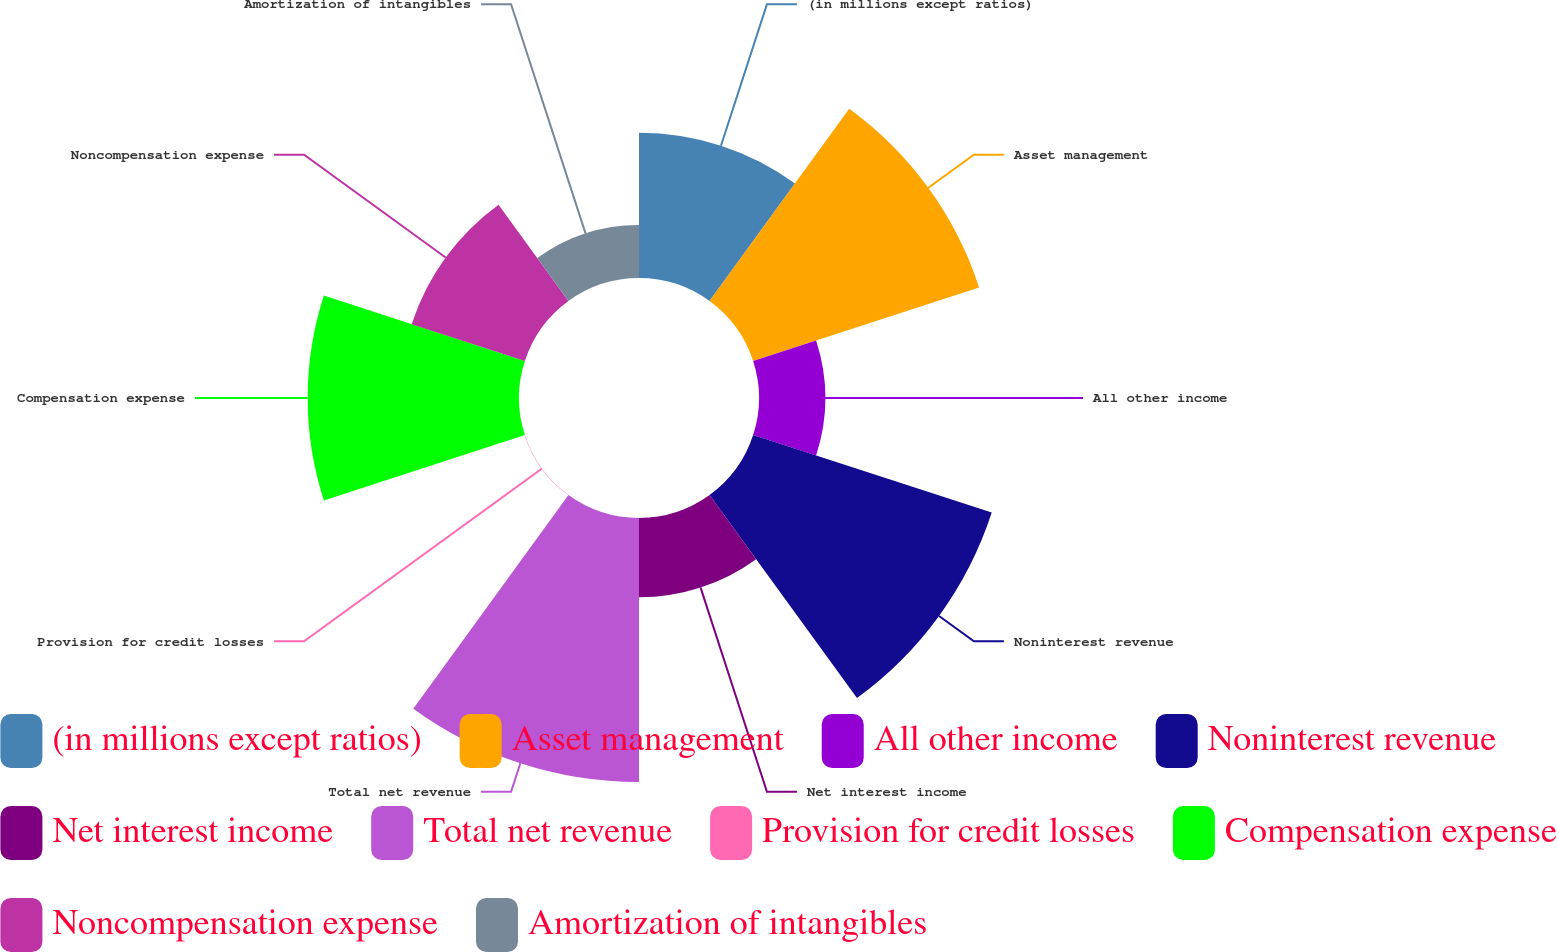Convert chart. <chart><loc_0><loc_0><loc_500><loc_500><pie_chart><fcel>(in millions except ratios)<fcel>Asset management<fcel>All other income<fcel>Noninterest revenue<fcel>Net interest income<fcel>Total net revenue<fcel>Provision for credit losses<fcel>Compensation expense<fcel>Noncompensation expense<fcel>Amortization of intangibles<nl><fcel>10.18%<fcel>16.65%<fcel>4.64%<fcel>17.58%<fcel>5.56%<fcel>18.5%<fcel>0.02%<fcel>14.81%<fcel>8.34%<fcel>3.72%<nl></chart> 